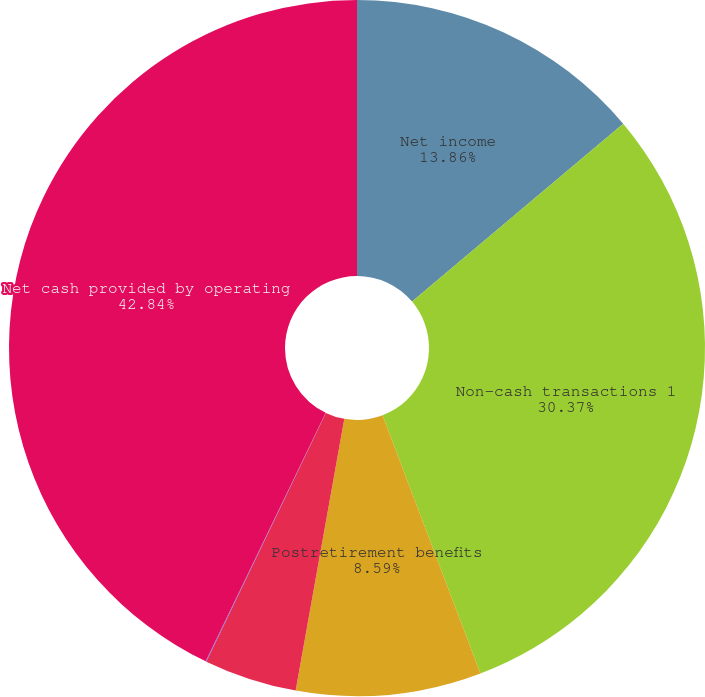Convert chart. <chart><loc_0><loc_0><loc_500><loc_500><pie_chart><fcel>Net income<fcel>Non-cash transactions 1<fcel>Postretirement benefits<fcel>Changes in core working<fcel>Changes in other assets and<fcel>Net cash provided by operating<nl><fcel>13.86%<fcel>30.37%<fcel>8.59%<fcel>4.31%<fcel>0.03%<fcel>42.84%<nl></chart> 